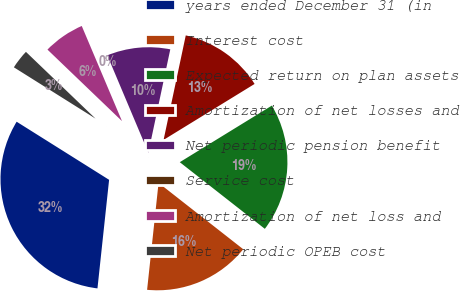Convert chart to OTSL. <chart><loc_0><loc_0><loc_500><loc_500><pie_chart><fcel>years ended December 31 (in<fcel>Interest cost<fcel>Expected return on plan assets<fcel>Amortization of net losses and<fcel>Net periodic pension benefit<fcel>Service cost<fcel>Amortization of net loss and<fcel>Net periodic OPEB cost<nl><fcel>32.23%<fcel>16.12%<fcel>19.35%<fcel>12.9%<fcel>9.68%<fcel>0.02%<fcel>6.46%<fcel>3.24%<nl></chart> 